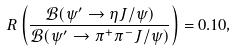<formula> <loc_0><loc_0><loc_500><loc_500>R \left ( \frac { \mathcal { B } ( \psi ^ { \prime } \to \eta J / \psi ) } { \mathcal { B } ( \psi ^ { \prime } \to \pi ^ { + } \pi ^ { - } J / \psi ) } \right ) = 0 . 1 0 ,</formula> 